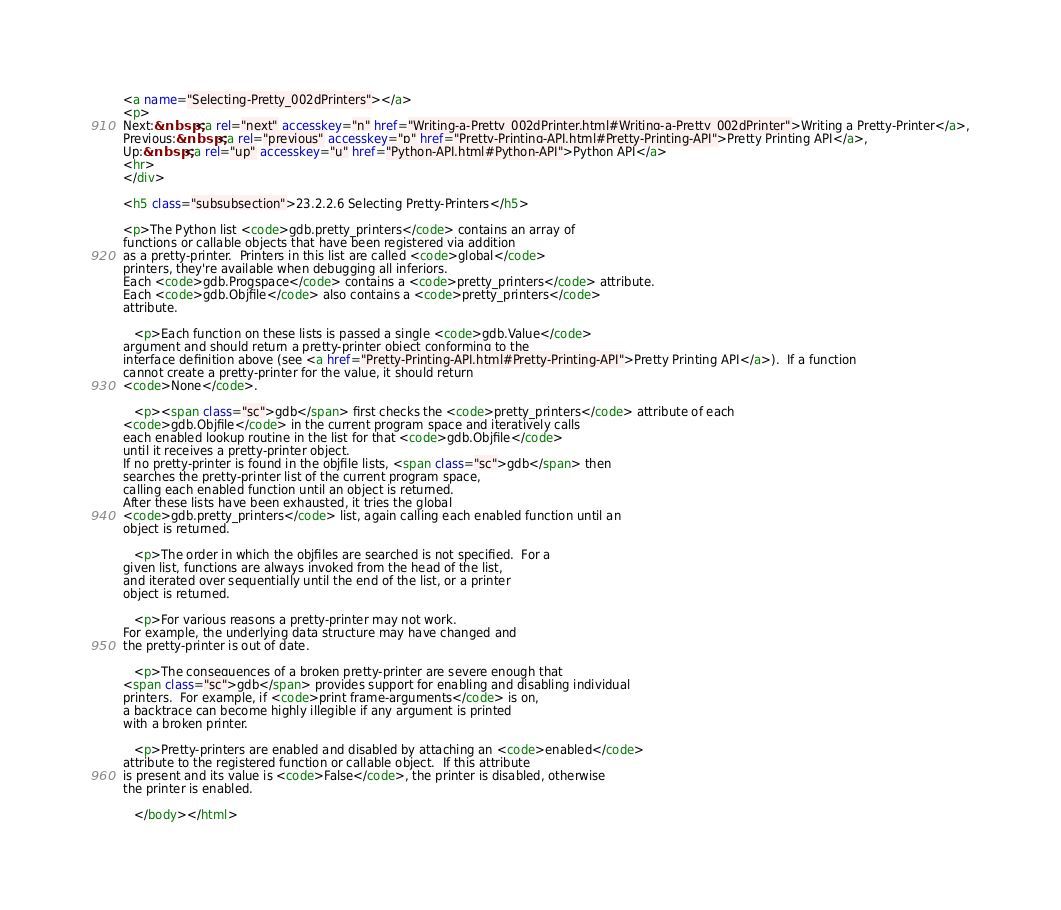Convert code to text. <code><loc_0><loc_0><loc_500><loc_500><_HTML_><a name="Selecting-Pretty_002dPrinters"></a>
<p>
Next:&nbsp;<a rel="next" accesskey="n" href="Writing-a-Pretty_002dPrinter.html#Writing-a-Pretty_002dPrinter">Writing a Pretty-Printer</a>,
Previous:&nbsp;<a rel="previous" accesskey="p" href="Pretty-Printing-API.html#Pretty-Printing-API">Pretty Printing API</a>,
Up:&nbsp;<a rel="up" accesskey="u" href="Python-API.html#Python-API">Python API</a>
<hr>
</div>

<h5 class="subsubsection">23.2.2.6 Selecting Pretty-Printers</h5>

<p>The Python list <code>gdb.pretty_printers</code> contains an array of
functions or callable objects that have been registered via addition
as a pretty-printer.  Printers in this list are called <code>global</code>
printers, they're available when debugging all inferiors. 
Each <code>gdb.Progspace</code> contains a <code>pretty_printers</code> attribute. 
Each <code>gdb.Objfile</code> also contains a <code>pretty_printers</code>
attribute.

   <p>Each function on these lists is passed a single <code>gdb.Value</code>
argument and should return a pretty-printer object conforming to the
interface definition above (see <a href="Pretty-Printing-API.html#Pretty-Printing-API">Pretty Printing API</a>).  If a function
cannot create a pretty-printer for the value, it should return
<code>None</code>.

   <p><span class="sc">gdb</span> first checks the <code>pretty_printers</code> attribute of each
<code>gdb.Objfile</code> in the current program space and iteratively calls
each enabled lookup routine in the list for that <code>gdb.Objfile</code>
until it receives a pretty-printer object. 
If no pretty-printer is found in the objfile lists, <span class="sc">gdb</span> then
searches the pretty-printer list of the current program space,
calling each enabled function until an object is returned. 
After these lists have been exhausted, it tries the global
<code>gdb.pretty_printers</code> list, again calling each enabled function until an
object is returned.

   <p>The order in which the objfiles are searched is not specified.  For a
given list, functions are always invoked from the head of the list,
and iterated over sequentially until the end of the list, or a printer
object is returned.

   <p>For various reasons a pretty-printer may not work. 
For example, the underlying data structure may have changed and
the pretty-printer is out of date.

   <p>The consequences of a broken pretty-printer are severe enough that
<span class="sc">gdb</span> provides support for enabling and disabling individual
printers.  For example, if <code>print frame-arguments</code> is on,
a backtrace can become highly illegible if any argument is printed
with a broken printer.

   <p>Pretty-printers are enabled and disabled by attaching an <code>enabled</code>
attribute to the registered function or callable object.  If this attribute
is present and its value is <code>False</code>, the printer is disabled, otherwise
the printer is enabled.

   </body></html>

</code> 